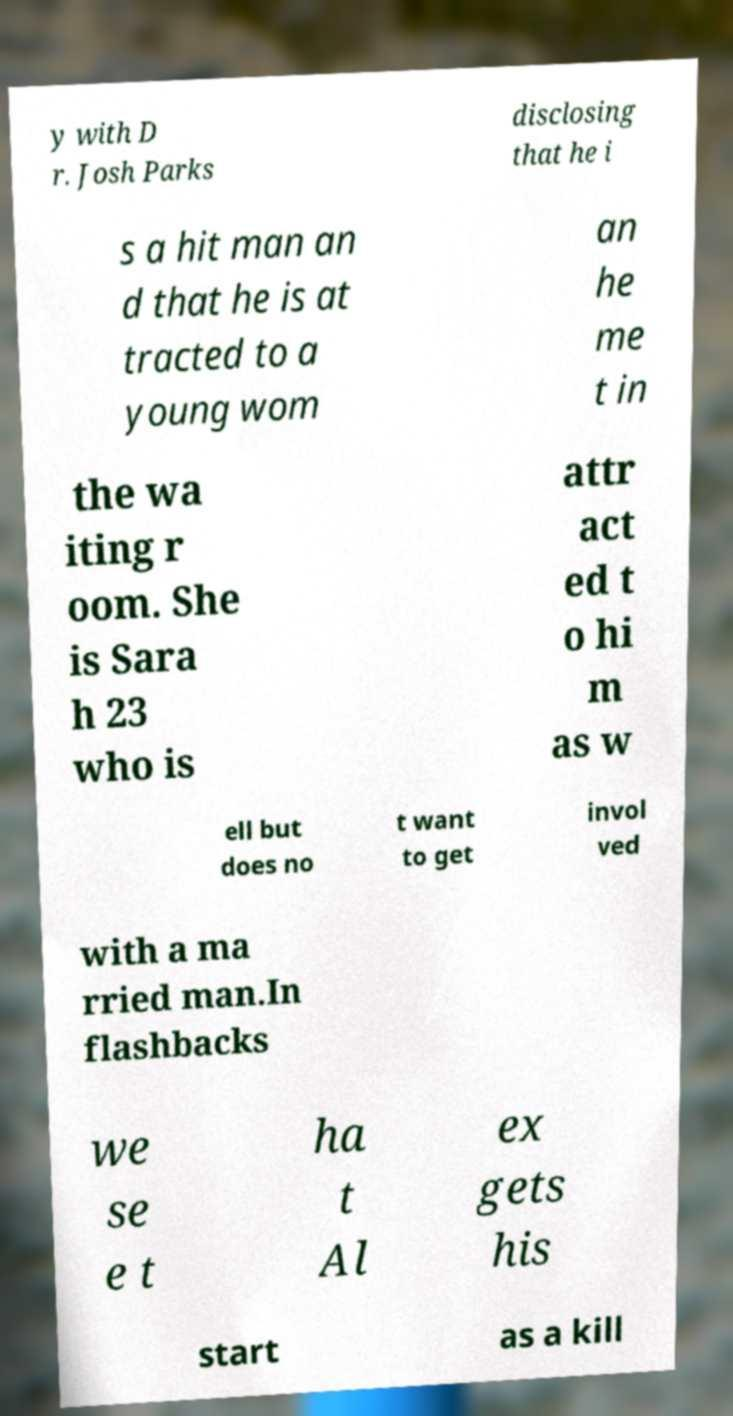There's text embedded in this image that I need extracted. Can you transcribe it verbatim? y with D r. Josh Parks disclosing that he i s a hit man an d that he is at tracted to a young wom an he me t in the wa iting r oom. She is Sara h 23 who is attr act ed t o hi m as w ell but does no t want to get invol ved with a ma rried man.In flashbacks we se e t ha t Al ex gets his start as a kill 